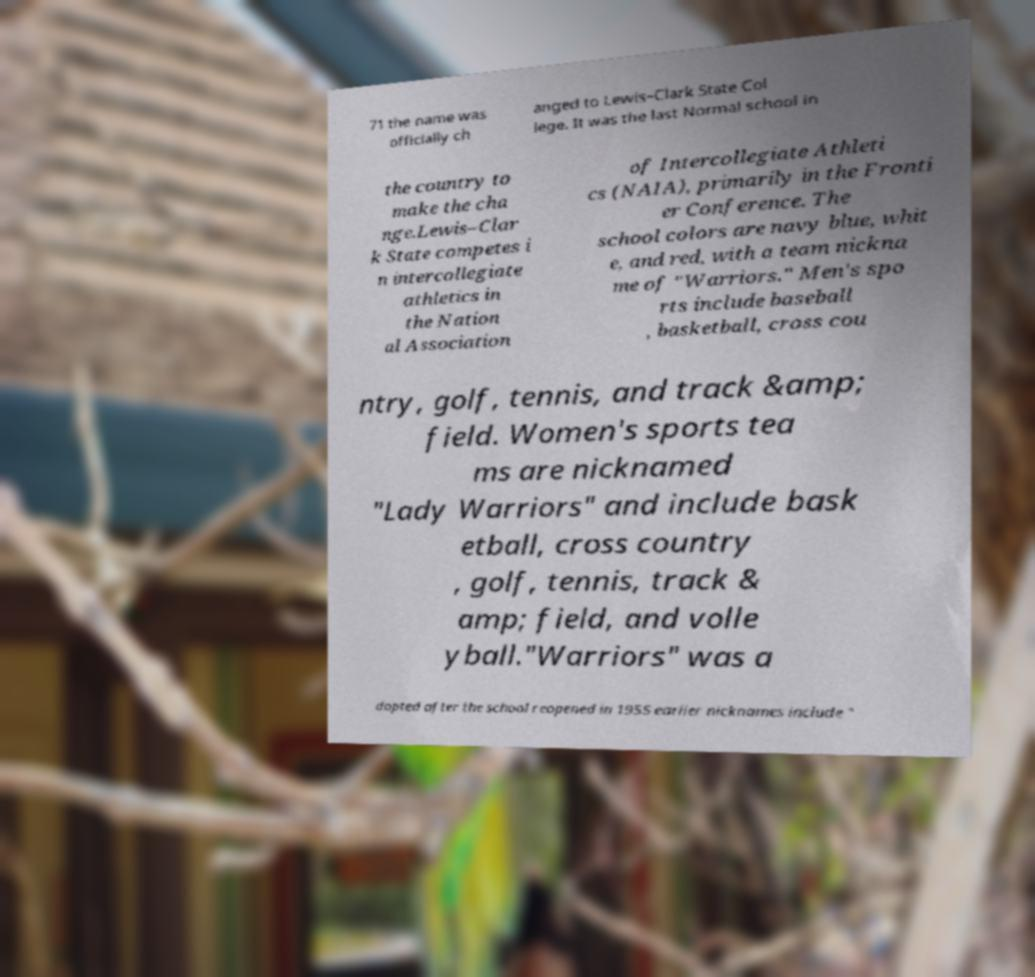Please read and relay the text visible in this image. What does it say? 71 the name was officially ch anged to Lewis–Clark State Col lege. It was the last Normal school in the country to make the cha nge.Lewis–Clar k State competes i n intercollegiate athletics in the Nation al Association of Intercollegiate Athleti cs (NAIA), primarily in the Fronti er Conference. The school colors are navy blue, whit e, and red, with a team nickna me of "Warriors." Men's spo rts include baseball , basketball, cross cou ntry, golf, tennis, and track &amp; field. Women's sports tea ms are nicknamed "Lady Warriors" and include bask etball, cross country , golf, tennis, track & amp; field, and volle yball."Warriors" was a dopted after the school reopened in 1955 earlier nicknames include " 